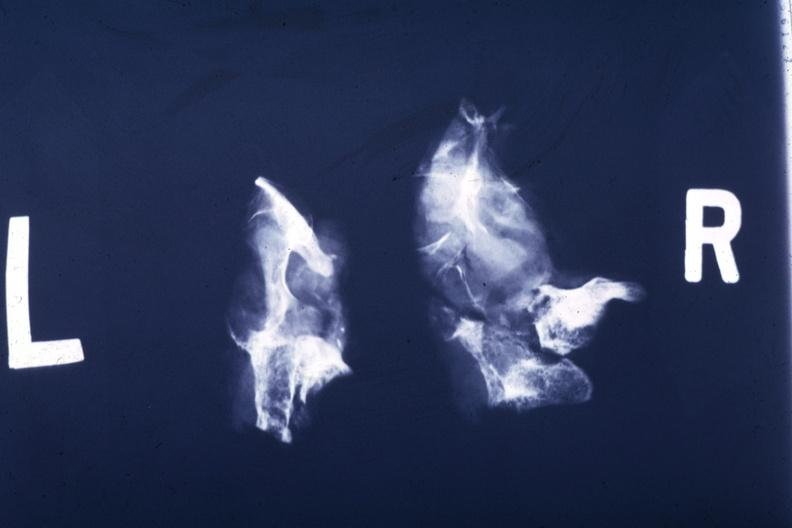what shows partially destroyed bone and large soft tissue mass?
Answer the question using a single word or phrase. This x-ray of sella turcica after removal postmort 